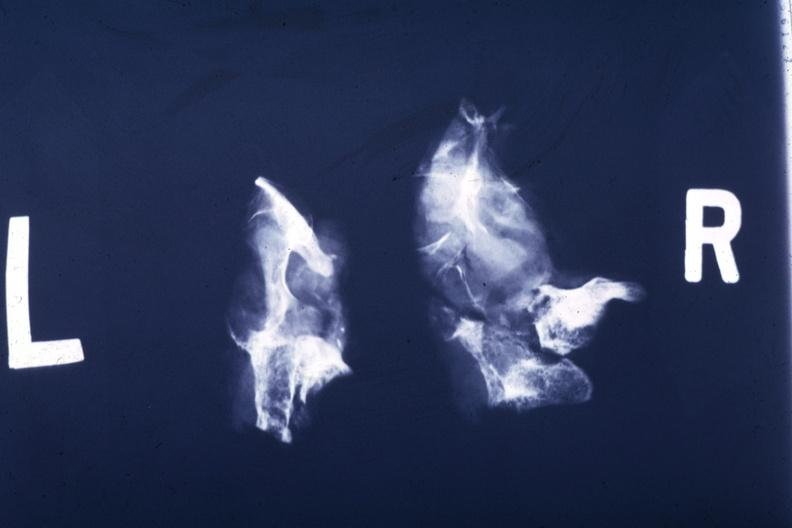what shows partially destroyed bone and large soft tissue mass?
Answer the question using a single word or phrase. This x-ray of sella turcica after removal postmort 